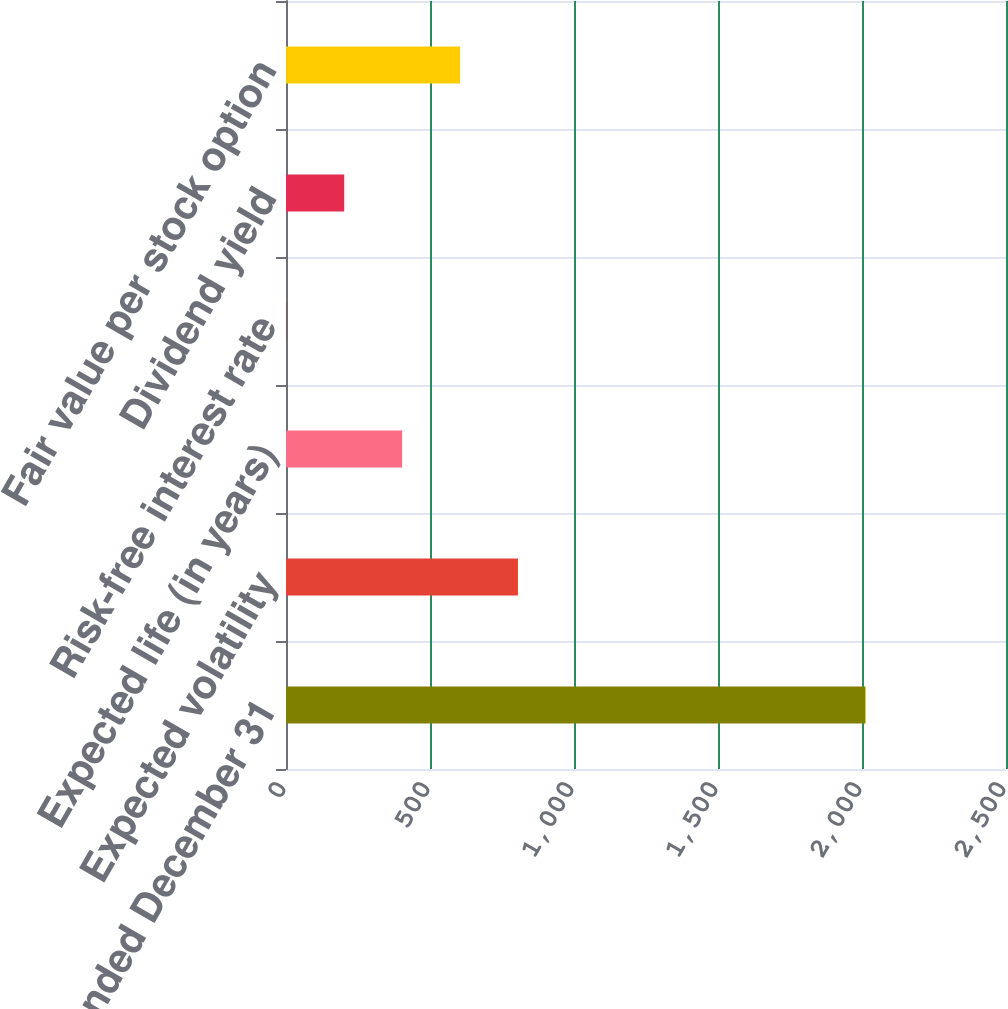Convert chart. <chart><loc_0><loc_0><loc_500><loc_500><bar_chart><fcel>years ended December 31<fcel>Expected volatility<fcel>Expected life (in years)<fcel>Risk-free interest rate<fcel>Dividend yield<fcel>Fair value per stock option<nl><fcel>2012<fcel>805.4<fcel>403.2<fcel>1<fcel>202.1<fcel>604.3<nl></chart> 